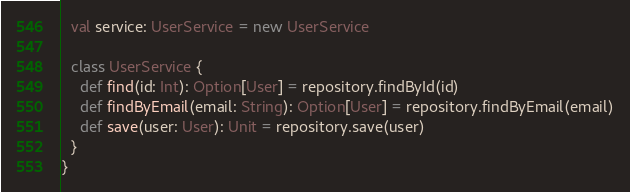<code> <loc_0><loc_0><loc_500><loc_500><_Scala_>  val service: UserService = new UserService

  class UserService {
    def find(id: Int): Option[User] = repository.findById(id)
    def findByEmail(email: String): Option[User] = repository.findByEmail(email)
    def save(user: User): Unit = repository.save(user)
  }
}
</code> 